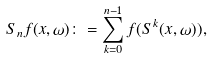Convert formula to latex. <formula><loc_0><loc_0><loc_500><loc_500>S _ { n } f ( x , \omega ) \colon = \sum _ { k = 0 } ^ { n - 1 } f ( S ^ { k } ( x , \omega ) ) ,</formula> 